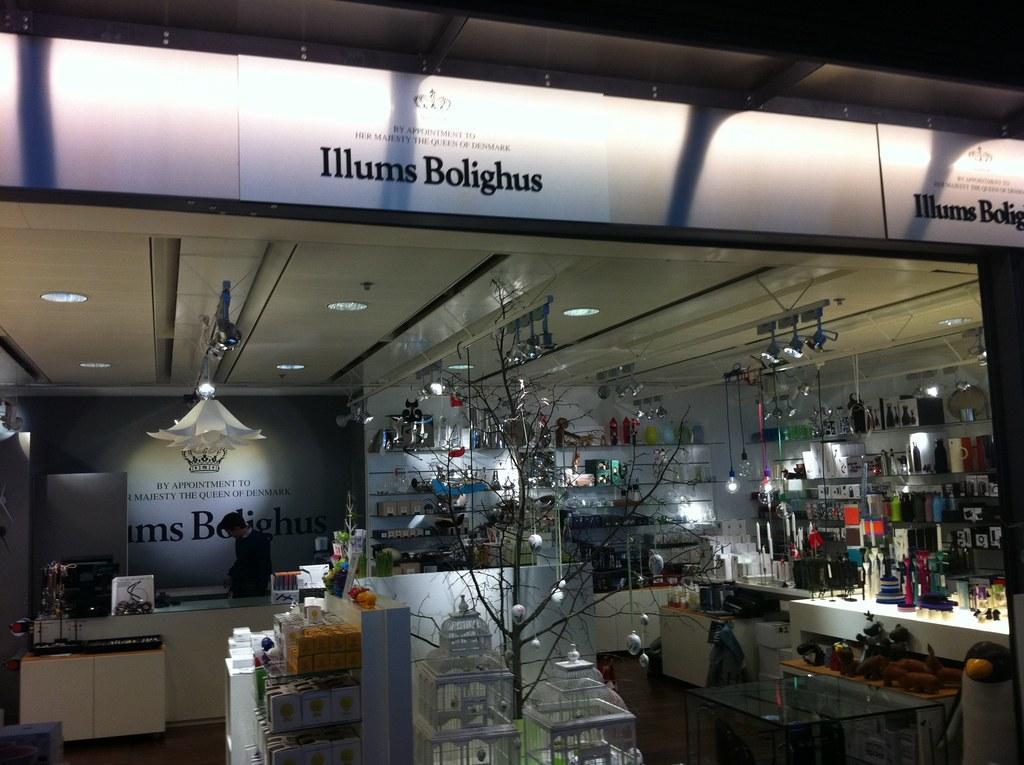Can you describe this image briefly? In this picture we can see plant which is on the table. On the table we can see boxes, bottles and other objects. On the left there is a man is wearing black color dress, standing near to the table. On the top we can see name of the shop. Here we can see chandelier and lights. On the right we can see cotton boxes, bottles, jar, glass bottles and other objects in the rack. 